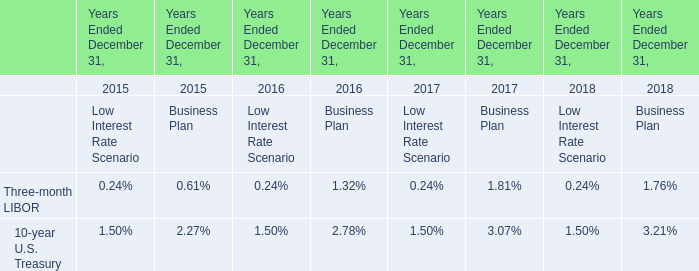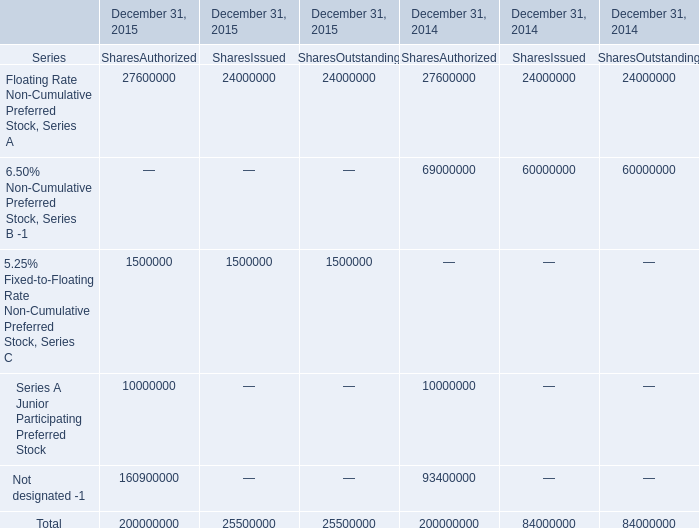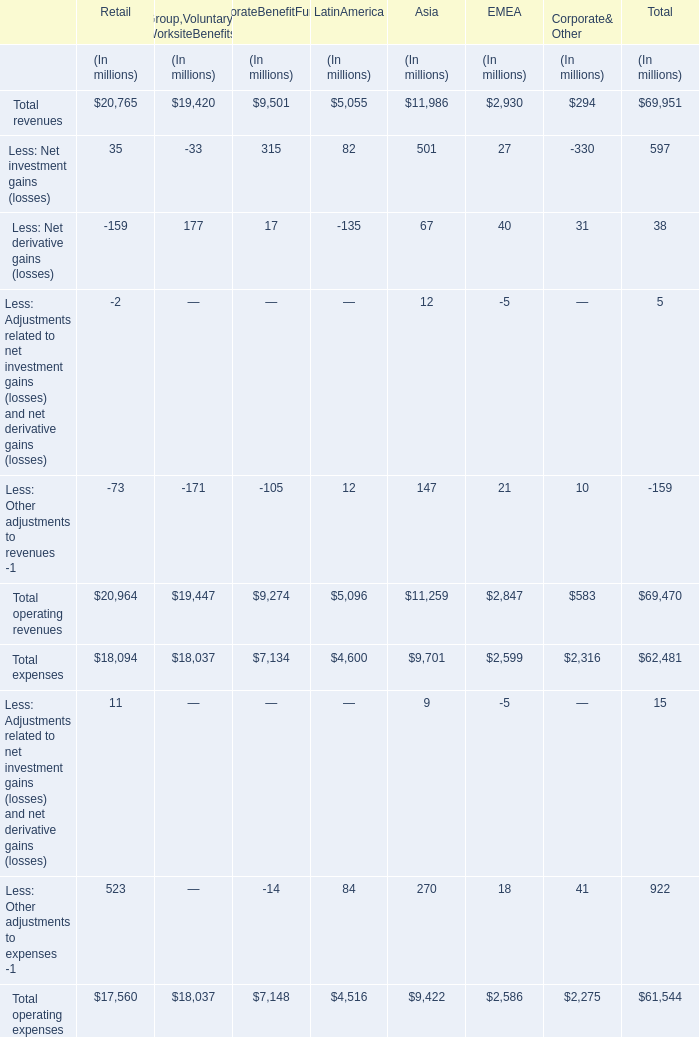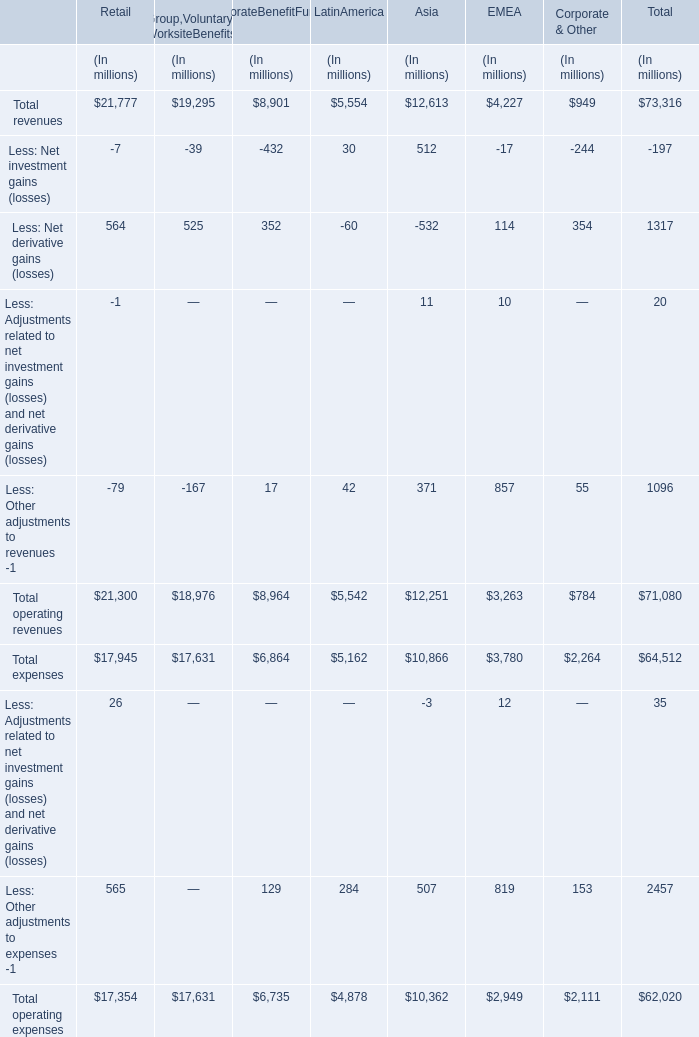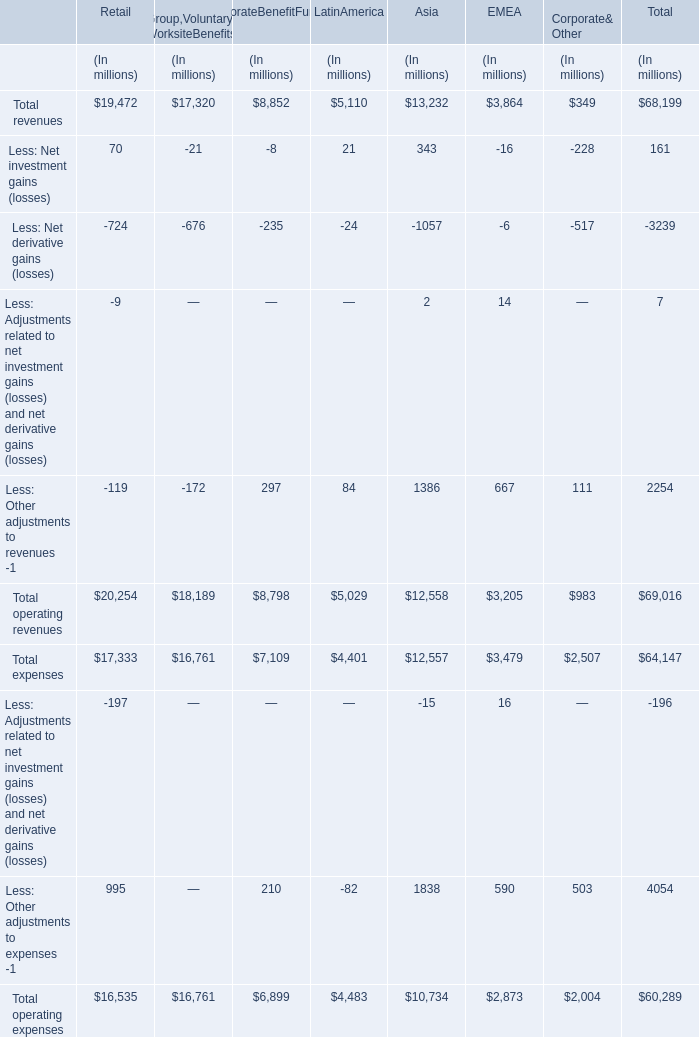What is the average value of Total revenues in Retail ,Group,Voluntary& WorksiteBenefits and CorporateBenefitFunding (in million) 
Computations: (((19472 + 17320) + 8852) / 3)
Answer: 15214.66667. 